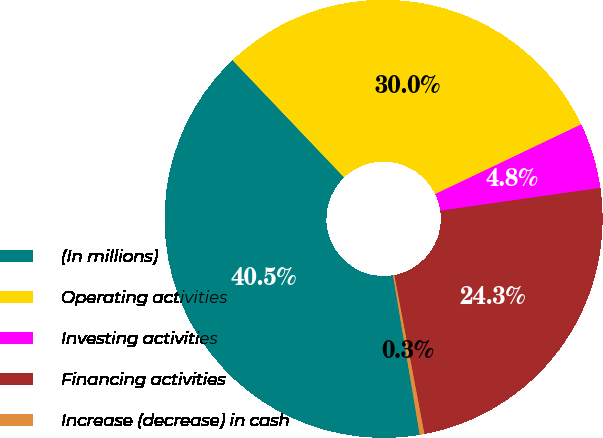<chart> <loc_0><loc_0><loc_500><loc_500><pie_chart><fcel>(In millions)<fcel>Operating activities<fcel>Investing activities<fcel>Financing activities<fcel>Increase (decrease) in cash<nl><fcel>40.53%<fcel>30.01%<fcel>4.84%<fcel>24.27%<fcel>0.34%<nl></chart> 